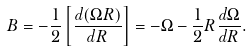<formula> <loc_0><loc_0><loc_500><loc_500>B = - \frac { 1 } { 2 } \left [ \frac { d ( \Omega R ) } { d R } \right ] = - \Omega - \frac { 1 } { 2 } R \frac { d \Omega } { d R } .</formula> 